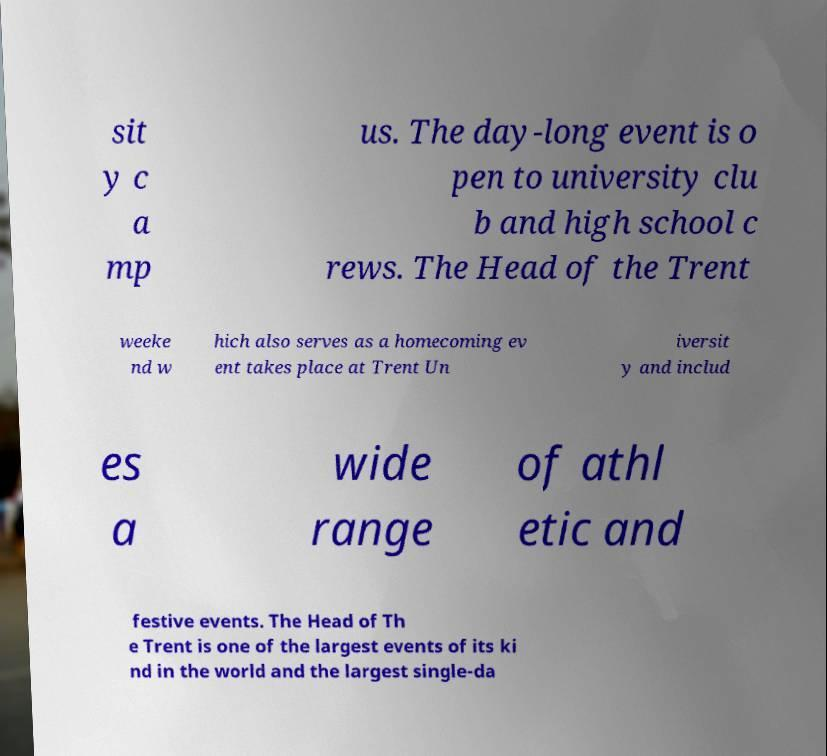Please read and relay the text visible in this image. What does it say? sit y c a mp us. The day-long event is o pen to university clu b and high school c rews. The Head of the Trent weeke nd w hich also serves as a homecoming ev ent takes place at Trent Un iversit y and includ es a wide range of athl etic and festive events. The Head of Th e Trent is one of the largest events of its ki nd in the world and the largest single-da 